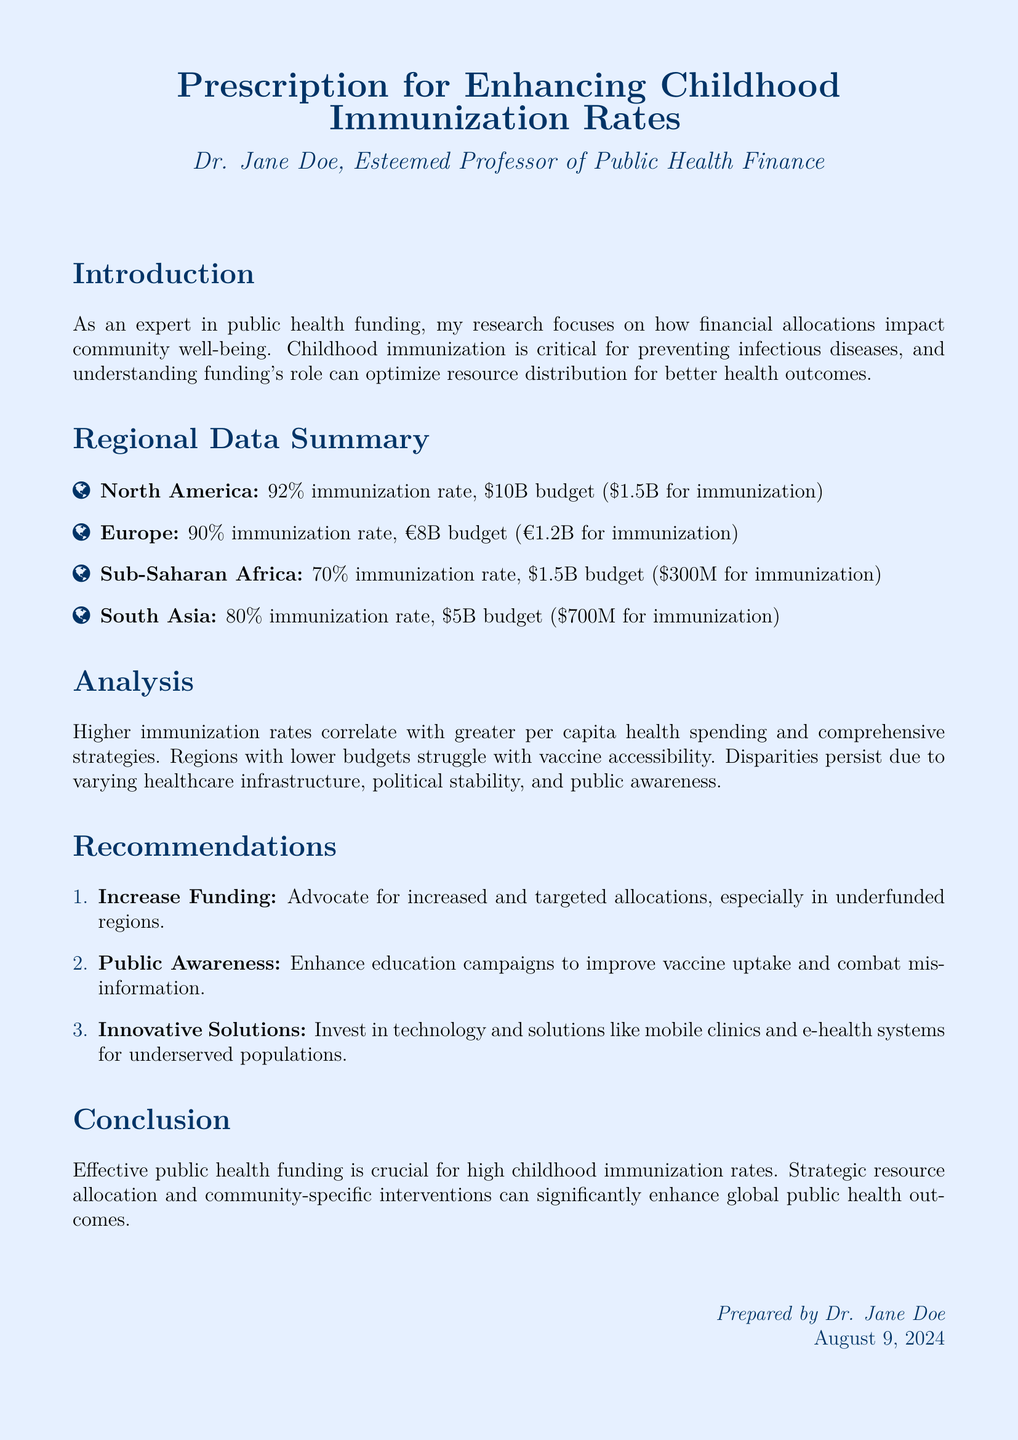What is the immunization rate in North America? The immmunization rate in North America is stated in the document as 92%.
Answer: 92% How much is the budget for childhood immunization in Sub-Saharan Africa? The budget allocated for childhood immunization in Sub-Saharan Africa is mentioned as $300 million.
Answer: $300 million What percentage of the budget for Europe is allocated for immunization? The allocation for immunization in Europe, given the overall budget, shows €1.2 billion is out of €8 billion, which is 15%.
Answer: 15% Which region has the highest immunization rate? The highest immunization rate among the listed regions is found in North America at 92%.
Answer: North America What is the total budget for South Asia? The total budget for South Asia is indicated in the document as $5 billion.
Answer: $5 billion Which key area requires improvement according to the recommendations? The recommendations suggest that public awareness, particularly through education campaigns, requires improvement.
Answer: Public awareness What is the main focus of the introduction? The introduction focuses on the relationship between public health funding and community well-being, particularly in childhood immunization.
Answer: Public health funding What is a suggested innovative solution to improve immunization rates? The document recommends investing in technology solutions like mobile clinics and e-health systems.
Answer: Mobile clinics What does increased health spending correlate with, as mentioned in the analysis? The analysis indicates that higher immunization rates correlate with greater per capita health spending.
Answer: Greater per capita health spending Which researcher prepared the document? The document states that it was prepared by Dr. Jane Doe.
Answer: Dr. Jane Doe 